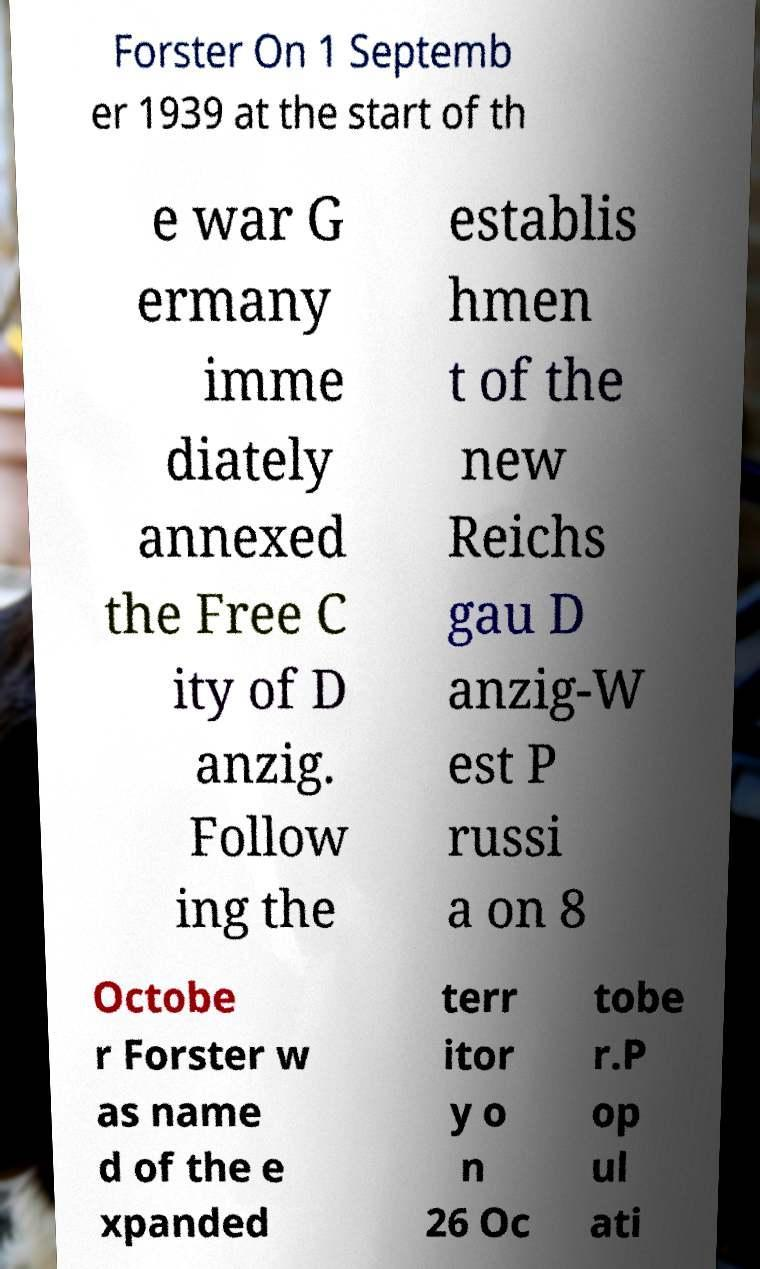Please read and relay the text visible in this image. What does it say? Forster On 1 Septemb er 1939 at the start of th e war G ermany imme diately annexed the Free C ity of D anzig. Follow ing the establis hmen t of the new Reichs gau D anzig-W est P russi a on 8 Octobe r Forster w as name d of the e xpanded terr itor y o n 26 Oc tobe r.P op ul ati 